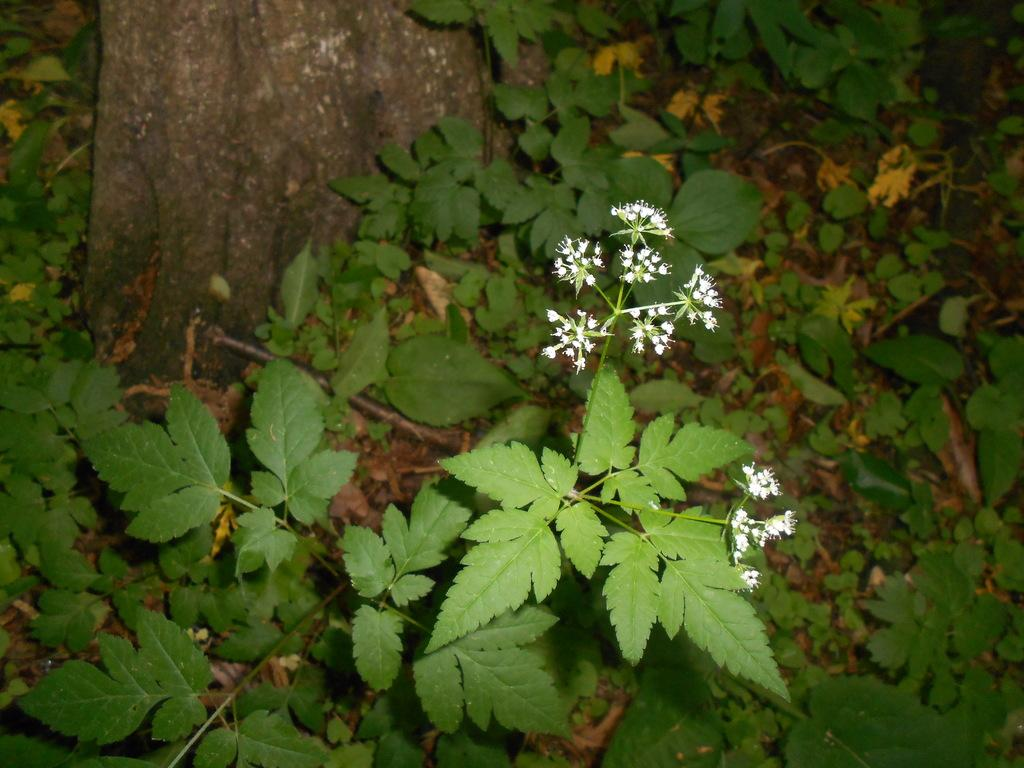What color are the flowers in the image? The flowers in the image are white. What are the flowers growing on? The flowers are on plants. What can be seen in the background of the image? There is a trunk visible in the background of the image, and there are small plants on the ground. How does the self-awareness of the flowers impact their growth in the image? The flowers in the image do not have self-awareness, as they are inanimate objects. 